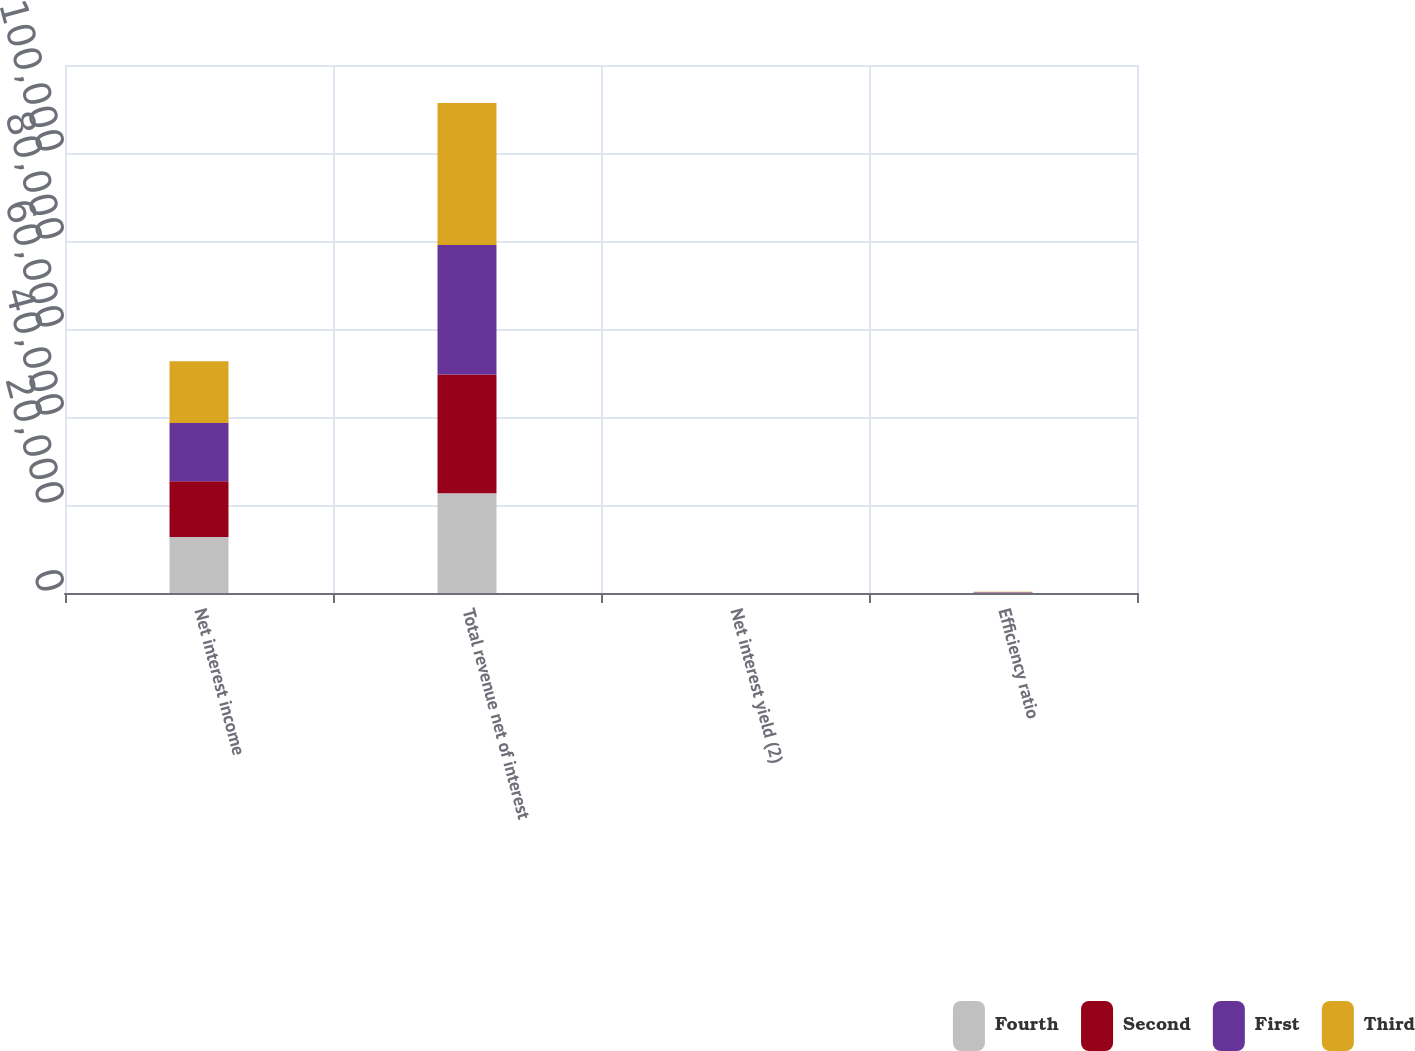Convert chart to OTSL. <chart><loc_0><loc_0><loc_500><loc_500><stacked_bar_chart><ecel><fcel>Net interest income<fcel>Total revenue net of interest<fcel>Net interest yield (2)<fcel>Efficiency ratio<nl><fcel>Fourth<fcel>12709<fcel>22668<fcel>2.69<fcel>92.04<nl><fcel>Second<fcel>12717<fcel>26982<fcel>2.72<fcel>100.87<nl><fcel>First<fcel>13197<fcel>29450<fcel>2.77<fcel>58.58<nl><fcel>Third<fcel>14070<fcel>32290<fcel>2.93<fcel>55.05<nl></chart> 